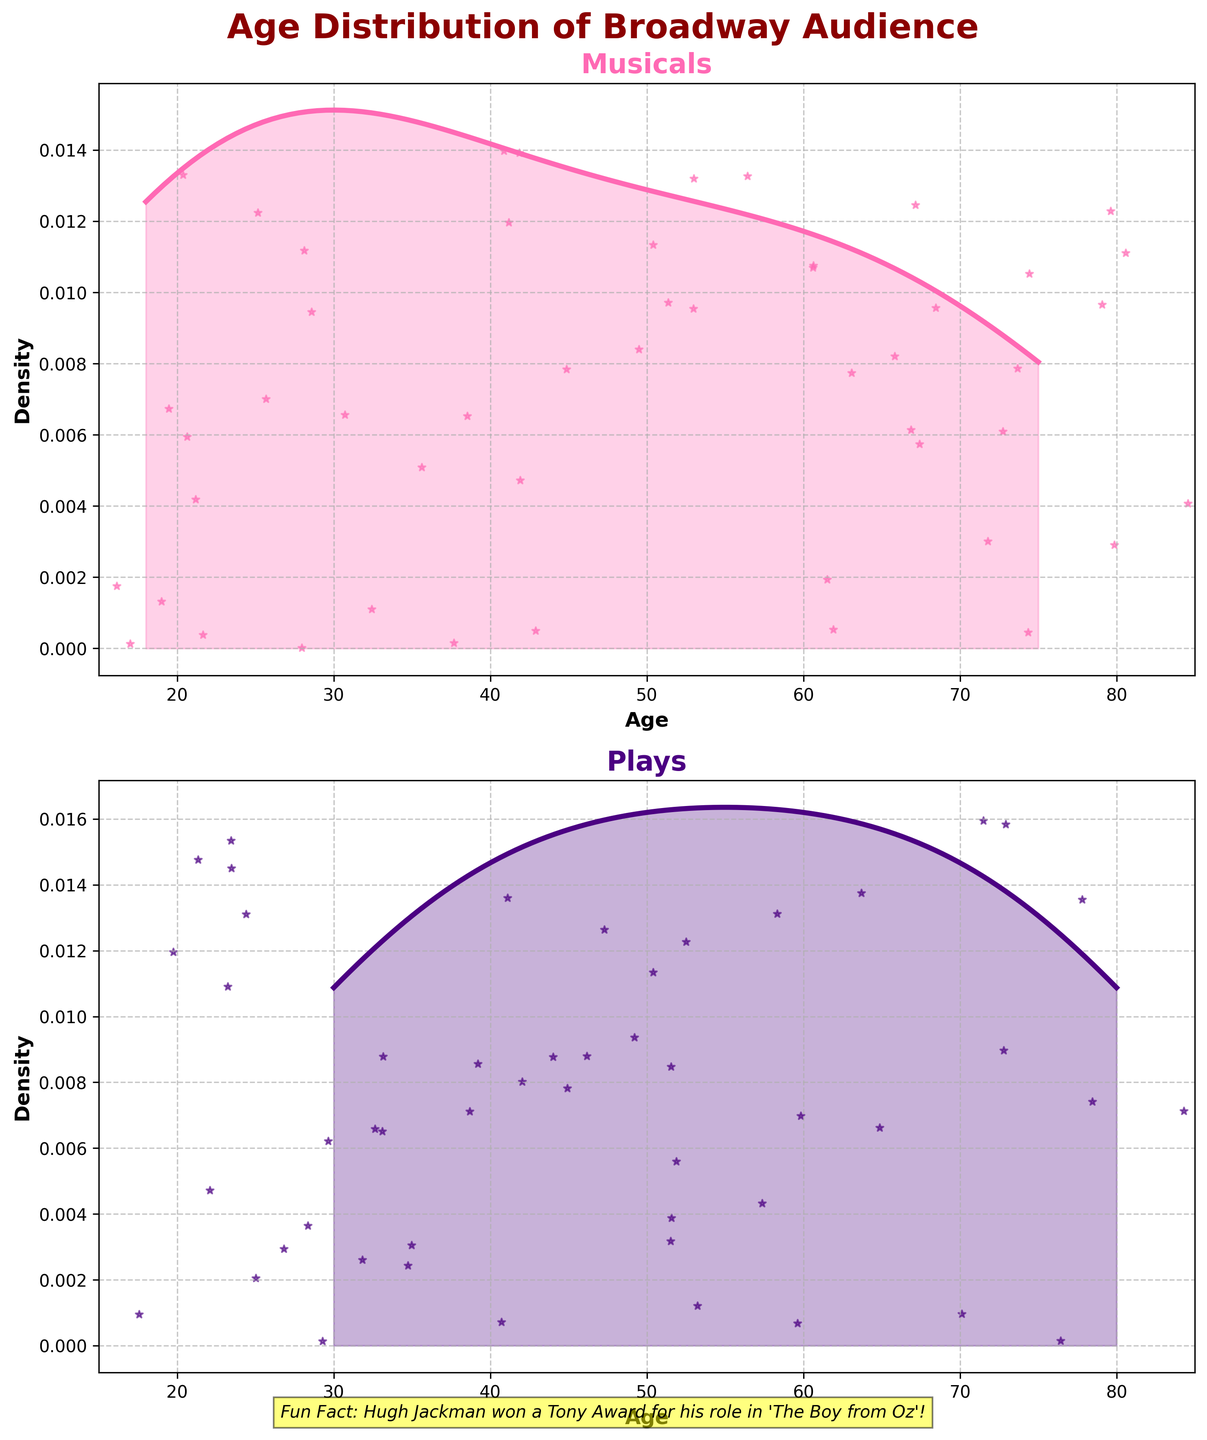What is the title of the figure? The title is typically displayed at the top of the figure. It helps to understand what the overall plot is representing. In this case, check the main title at the top center.
Answer: Age Distribution of Broadway Audience What are the two categories compared in the density plots? Look at the titles above the two subplots. Each plot title represents a category.
Answer: Musicals and Plays What color represents the density plot for musicals? Observe the color of the line and the filled area in the subplot titled "Musicals."
Answer: Hot Pink What is the age range covered in the plots? Check the x-axis labels of both subplots to see the minimum and maximum values.
Answer: 15 to 85 Which category has a higher density peak? Compare the height of the peaks in both density plots.
Answer: Musicals What is the fun fact mentioned at the bottom of the figure? Read the text at the bottom of the figure, often included for engagement.
Answer: Hugh Jackman won a Tony Award for his role in 'The Boy from Oz.' How does the density distribution for plays compare to that for musicals? Observe the general shape and spread of both density plots from left to right.
Answer: Plays have a broader spread, while musicals have a more defined peak What is the approximate age where the density is the highest for musicals? Identify the peak of the density plot for musicals and read the corresponding age on the x-axis.
Answer: Around 40 years Are older audience members more evenly distributed for musicals or plays? Compare how the density changes with age for both plots, especially in the older age ranges.
Answer: Plays Which subplot includes a glitter effect, and what is its purpose? Look for star-like or scattered points on both subplots and note which one has it to understand added aesthetic elements.
Answer: Both plots; decorative purpose 